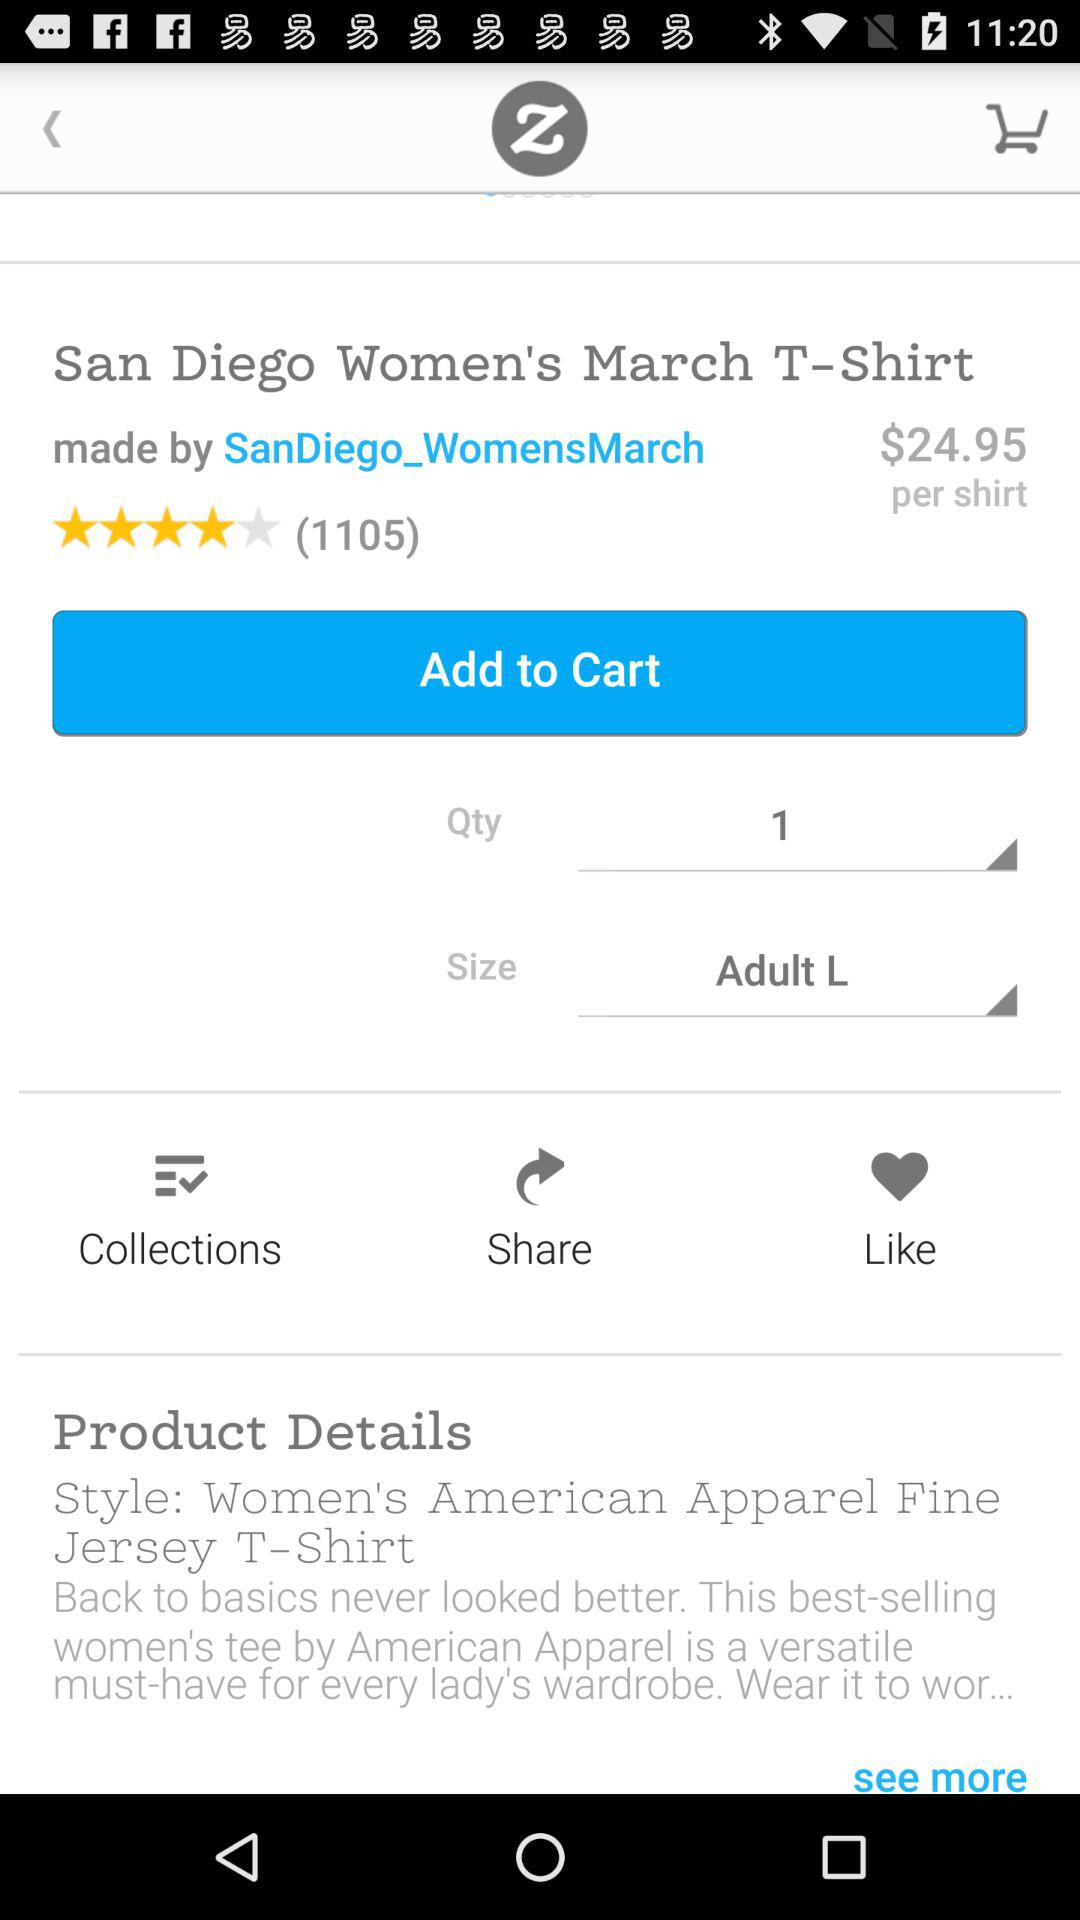What is the price per shirt?
Answer the question using a single word or phrase. $24.95 